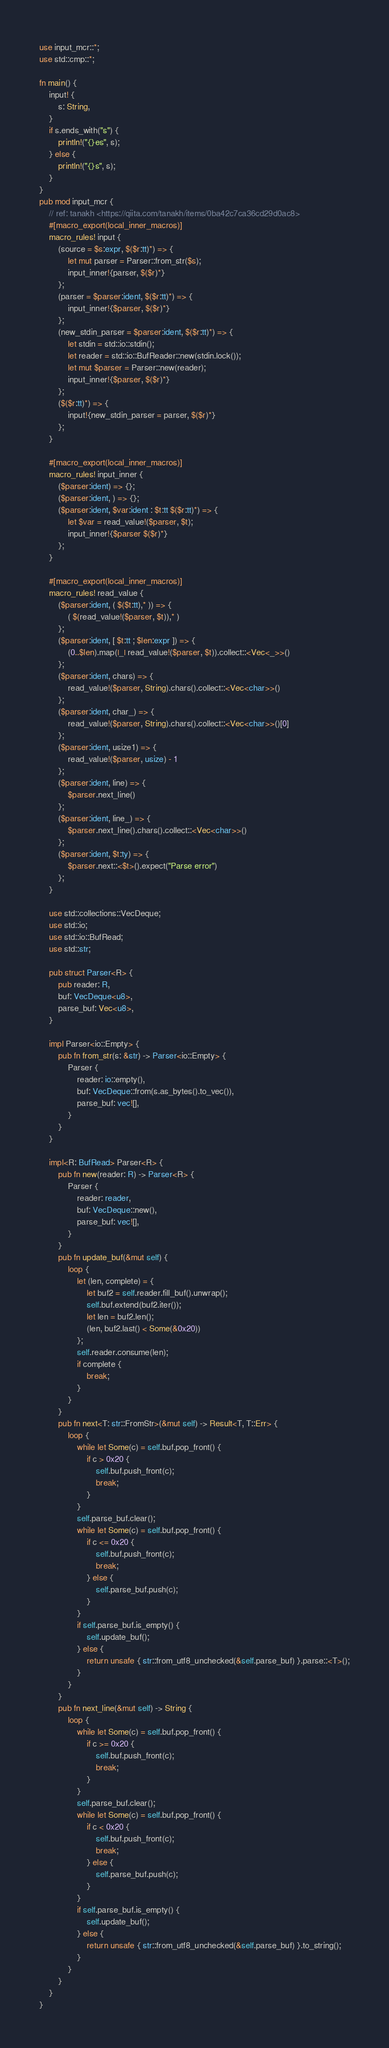<code> <loc_0><loc_0><loc_500><loc_500><_Rust_>use input_mcr::*;
use std::cmp::*;

fn main() {
    input! {
        s: String,
    }
    if s.ends_with("s") {
        println!("{}es", s);
    } else {
        println!("{}s", s);
    }
}
pub mod input_mcr {
    // ref: tanakh <https://qiita.com/tanakh/items/0ba42c7ca36cd29d0ac8>
    #[macro_export(local_inner_macros)]
    macro_rules! input {
        (source = $s:expr, $($r:tt)*) => {
            let mut parser = Parser::from_str($s);
            input_inner!{parser, $($r)*}
        };
        (parser = $parser:ident, $($r:tt)*) => {
            input_inner!{$parser, $($r)*}
        };
        (new_stdin_parser = $parser:ident, $($r:tt)*) => {
            let stdin = std::io::stdin();
            let reader = std::io::BufReader::new(stdin.lock());
            let mut $parser = Parser::new(reader);
            input_inner!{$parser, $($r)*}
        };
        ($($r:tt)*) => {
            input!{new_stdin_parser = parser, $($r)*}
        };
    }

    #[macro_export(local_inner_macros)]
    macro_rules! input_inner {
        ($parser:ident) => {};
        ($parser:ident, ) => {};
        ($parser:ident, $var:ident : $t:tt $($r:tt)*) => {
            let $var = read_value!($parser, $t);
            input_inner!{$parser $($r)*}
        };
    }

    #[macro_export(local_inner_macros)]
    macro_rules! read_value {
        ($parser:ident, ( $($t:tt),* )) => {
            ( $(read_value!($parser, $t)),* )
        };
        ($parser:ident, [ $t:tt ; $len:expr ]) => {
            (0..$len).map(|_| read_value!($parser, $t)).collect::<Vec<_>>()
        };
        ($parser:ident, chars) => {
            read_value!($parser, String).chars().collect::<Vec<char>>()
        };
        ($parser:ident, char_) => {
            read_value!($parser, String).chars().collect::<Vec<char>>()[0]
        };
        ($parser:ident, usize1) => {
            read_value!($parser, usize) - 1
        };
        ($parser:ident, line) => {
            $parser.next_line()
        };
        ($parser:ident, line_) => {
            $parser.next_line().chars().collect::<Vec<char>>()
        };
        ($parser:ident, $t:ty) => {
            $parser.next::<$t>().expect("Parse error")
        };
    }

    use std::collections::VecDeque;
    use std::io;
    use std::io::BufRead;
    use std::str;

    pub struct Parser<R> {
        pub reader: R,
        buf: VecDeque<u8>,
        parse_buf: Vec<u8>,
    }

    impl Parser<io::Empty> {
        pub fn from_str(s: &str) -> Parser<io::Empty> {
            Parser {
                reader: io::empty(),
                buf: VecDeque::from(s.as_bytes().to_vec()),
                parse_buf: vec![],
            }
        }
    }

    impl<R: BufRead> Parser<R> {
        pub fn new(reader: R) -> Parser<R> {
            Parser {
                reader: reader,
                buf: VecDeque::new(),
                parse_buf: vec![],
            }
        }
        pub fn update_buf(&mut self) {
            loop {
                let (len, complete) = {
                    let buf2 = self.reader.fill_buf().unwrap();
                    self.buf.extend(buf2.iter());
                    let len = buf2.len();
                    (len, buf2.last() < Some(&0x20))
                };
                self.reader.consume(len);
                if complete {
                    break;
                }
            }
        }
        pub fn next<T: str::FromStr>(&mut self) -> Result<T, T::Err> {
            loop {
                while let Some(c) = self.buf.pop_front() {
                    if c > 0x20 {
                        self.buf.push_front(c);
                        break;
                    }
                }
                self.parse_buf.clear();
                while let Some(c) = self.buf.pop_front() {
                    if c <= 0x20 {
                        self.buf.push_front(c);
                        break;
                    } else {
                        self.parse_buf.push(c);
                    }
                }
                if self.parse_buf.is_empty() {
                    self.update_buf();
                } else {
                    return unsafe { str::from_utf8_unchecked(&self.parse_buf) }.parse::<T>();
                }
            }
        }
        pub fn next_line(&mut self) -> String {
            loop {
                while let Some(c) = self.buf.pop_front() {
                    if c >= 0x20 {
                        self.buf.push_front(c);
                        break;
                    }
                }
                self.parse_buf.clear();
                while let Some(c) = self.buf.pop_front() {
                    if c < 0x20 {
                        self.buf.push_front(c);
                        break;
                    } else {
                        self.parse_buf.push(c);
                    }
                }
                if self.parse_buf.is_empty() {
                    self.update_buf();
                } else {
                    return unsafe { str::from_utf8_unchecked(&self.parse_buf) }.to_string();
                }
            }
        }
    }
}
</code> 